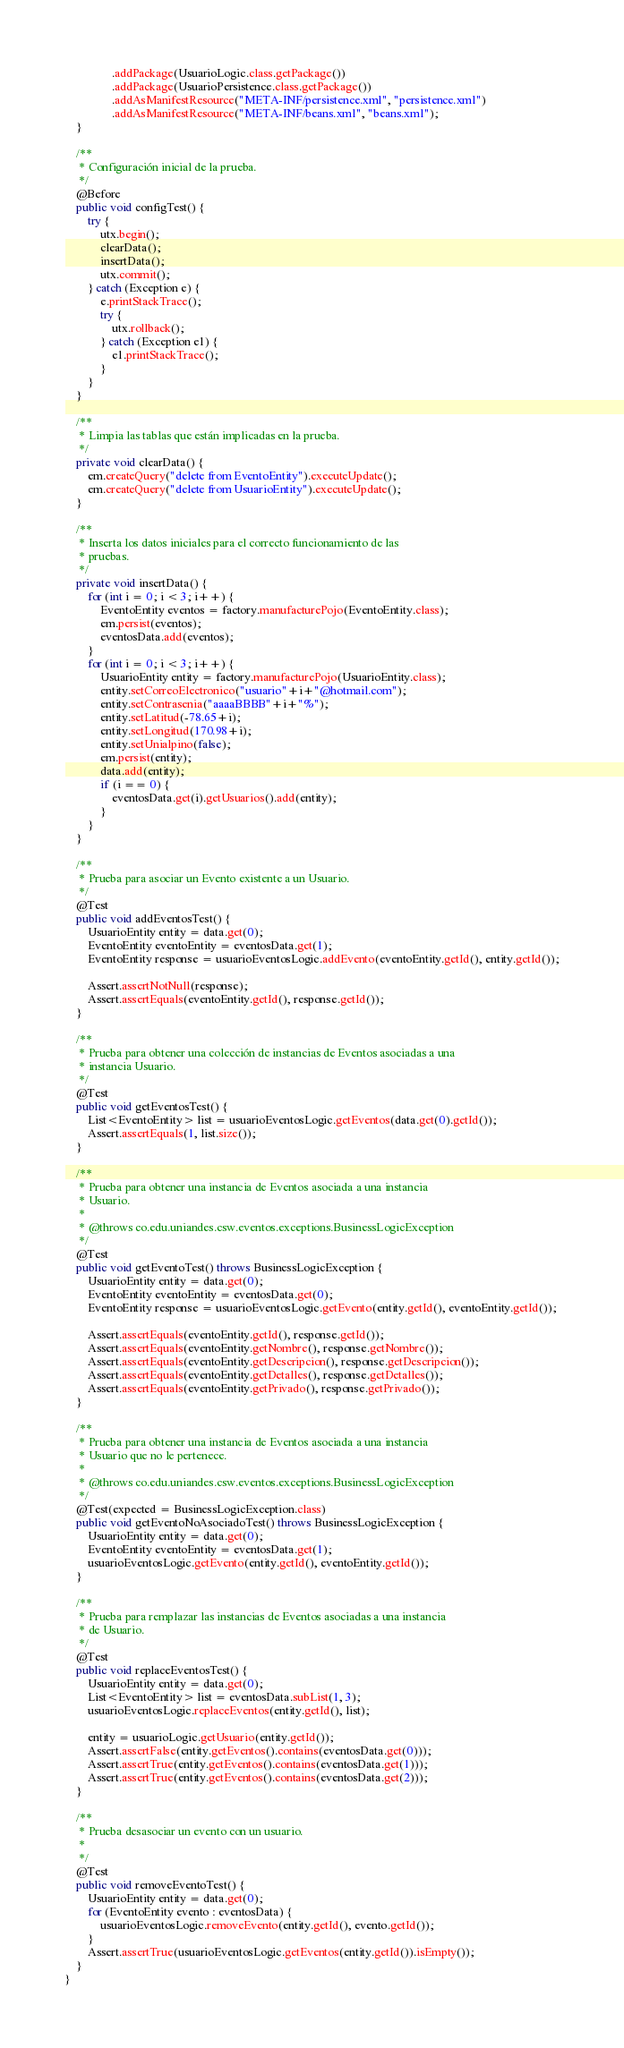Convert code to text. <code><loc_0><loc_0><loc_500><loc_500><_Java_>                .addPackage(UsuarioLogic.class.getPackage())
                .addPackage(UsuarioPersistence.class.getPackage())
                .addAsManifestResource("META-INF/persistence.xml", "persistence.xml")
                .addAsManifestResource("META-INF/beans.xml", "beans.xml");
    }

    /**
     * Configuración inicial de la prueba.
     */
    @Before
    public void configTest() {
        try {
            utx.begin();
            clearData();
            insertData();
            utx.commit();
        } catch (Exception e) {
            e.printStackTrace();
            try {
                utx.rollback();
            } catch (Exception e1) {
                e1.printStackTrace();
            }
        }
    }

    /**
     * Limpia las tablas que están implicadas en la prueba.
     */
    private void clearData() {
        em.createQuery("delete from EventoEntity").executeUpdate();
        em.createQuery("delete from UsuarioEntity").executeUpdate();
    }

    /**
     * Inserta los datos iniciales para el correcto funcionamiento de las
     * pruebas.
     */
    private void insertData() {
        for (int i = 0; i < 3; i++) {
            EventoEntity eventos = factory.manufacturePojo(EventoEntity.class);
            em.persist(eventos);
            eventosData.add(eventos);
        }
        for (int i = 0; i < 3; i++) {
            UsuarioEntity entity = factory.manufacturePojo(UsuarioEntity.class);
            entity.setCorreoElectronico("usuario"+i+"@hotmail.com");
            entity.setContrasenia("aaaaBBBB"+i+"%");
            entity.setLatitud(-78.65+i);
            entity.setLongitud(170.98+i);
            entity.setUnialpino(false);
            em.persist(entity);
            data.add(entity);
            if (i == 0) {
                eventosData.get(i).getUsuarios().add(entity);
            }
        }
    }

    /**
     * Prueba para asociar un Evento existente a un Usuario.
     */
    @Test
    public void addEventosTest() {
        UsuarioEntity entity = data.get(0);
        EventoEntity eventoEntity = eventosData.get(1);
        EventoEntity response = usuarioEventosLogic.addEvento(eventoEntity.getId(), entity.getId());

        Assert.assertNotNull(response);
        Assert.assertEquals(eventoEntity.getId(), response.getId());
    }

    /**
     * Prueba para obtener una colección de instancias de Eventos asociadas a una
     * instancia Usuario.
     */
    @Test
    public void getEventosTest() {
        List<EventoEntity> list = usuarioEventosLogic.getEventos(data.get(0).getId());
        Assert.assertEquals(1, list.size());
    }

    /**
     * Prueba para obtener una instancia de Eventos asociada a una instancia
     * Usuario.
     *
     * @throws co.edu.uniandes.csw.eventos.exceptions.BusinessLogicException
     */
    @Test
    public void getEventoTest() throws BusinessLogicException {
        UsuarioEntity entity = data.get(0);
        EventoEntity eventoEntity = eventosData.get(0);
        EventoEntity response = usuarioEventosLogic.getEvento(entity.getId(), eventoEntity.getId());

        Assert.assertEquals(eventoEntity.getId(), response.getId());
        Assert.assertEquals(eventoEntity.getNombre(), response.getNombre());
        Assert.assertEquals(eventoEntity.getDescripcion(), response.getDescripcion());
        Assert.assertEquals(eventoEntity.getDetalles(), response.getDetalles());
        Assert.assertEquals(eventoEntity.getPrivado(), response.getPrivado());
    }

    /**
     * Prueba para obtener una instancia de Eventos asociada a una instancia
     * Usuario que no le pertenece.
     *
     * @throws co.edu.uniandes.csw.eventos.exceptions.BusinessLogicException
     */
    @Test(expected = BusinessLogicException.class)
    public void getEventoNoAsociadoTest() throws BusinessLogicException {
        UsuarioEntity entity = data.get(0);
        EventoEntity eventoEntity = eventosData.get(1);
        usuarioEventosLogic.getEvento(entity.getId(), eventoEntity.getId());
    }

    /**
     * Prueba para remplazar las instancias de Eventos asociadas a una instancia
     * de Usuario.
     */
    @Test
    public void replaceEventosTest() {
        UsuarioEntity entity = data.get(0);
        List<EventoEntity> list = eventosData.subList(1, 3);
        usuarioEventosLogic.replaceEventos(entity.getId(), list);

        entity = usuarioLogic.getUsuario(entity.getId());
        Assert.assertFalse(entity.getEventos().contains(eventosData.get(0)));
        Assert.assertTrue(entity.getEventos().contains(eventosData.get(1)));
        Assert.assertTrue(entity.getEventos().contains(eventosData.get(2)));
    }
    
    /**
     * Prueba desasociar un evento con un usuario.
     *
     */
    @Test
    public void removeEventoTest() {
        UsuarioEntity entity = data.get(0);
        for (EventoEntity evento : eventosData) {
            usuarioEventosLogic.removeEvento(entity.getId(), evento.getId());
        }
        Assert.assertTrue(usuarioEventosLogic.getEventos(entity.getId()).isEmpty());
    }
}
</code> 